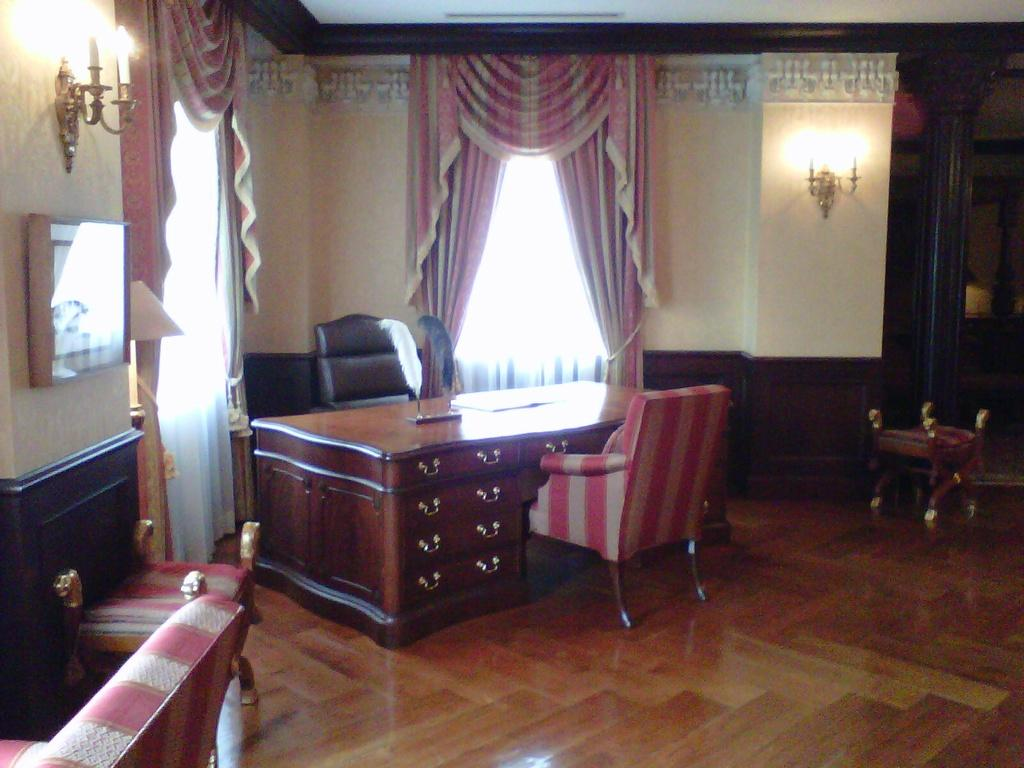What type of furniture is near the table in the image? There are two chairs near the table in the image. What can be seen providing light in the vicinity of the table? There is a lamp in the vicinity. What type of window treatment is present in the image? There are curtains on the wall. Can you describe the window in the image? There is a window in the image. What type of hose is used to water the plants in the image? There are no plants or hoses present in the image. What hobbies are the people in the image engaged in? There are no people or hobbies mentioned in the image. 